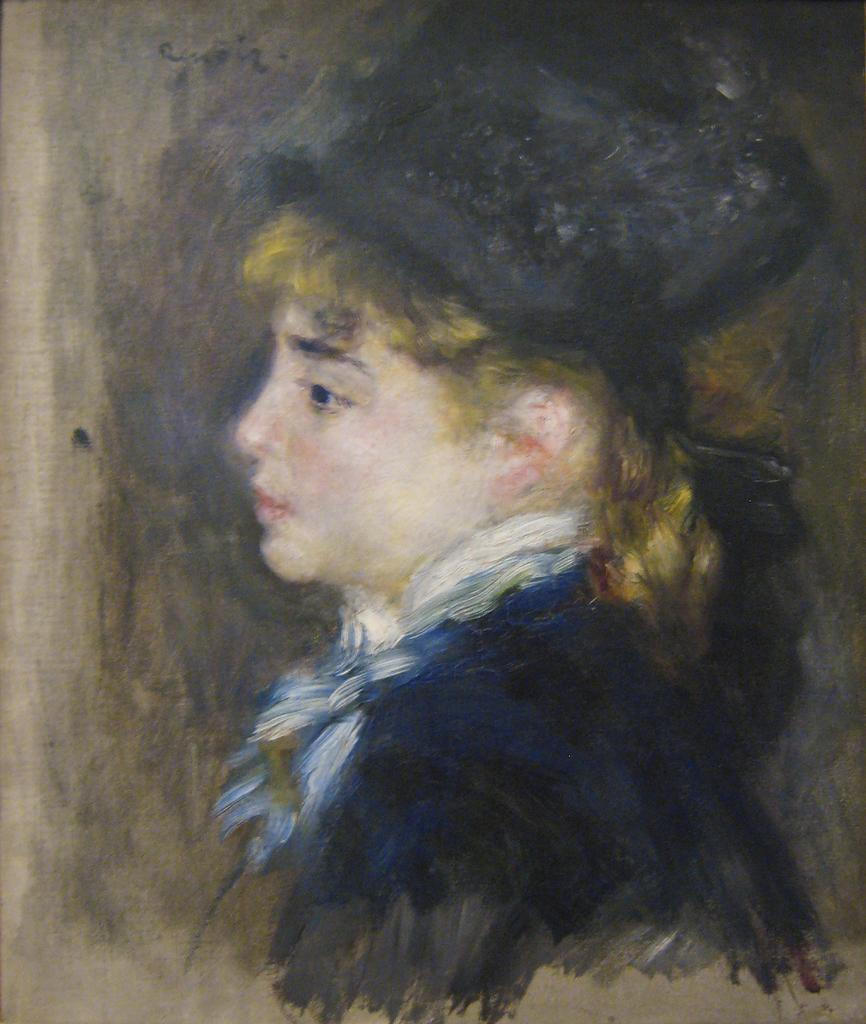What is the main subject of the image? There is a painting in the image. What does the painting depict? The painting depicts a person. On what object is the painting displayed? The painting is on an object that appears to be a wooden board. How many cats are visible in the image? There are no cats present in the image; it features a painting of a person on a wooden board. What type of lace is used to frame the painting in the image? There is no lace present in the image; the painting is displayed on a wooden board. 